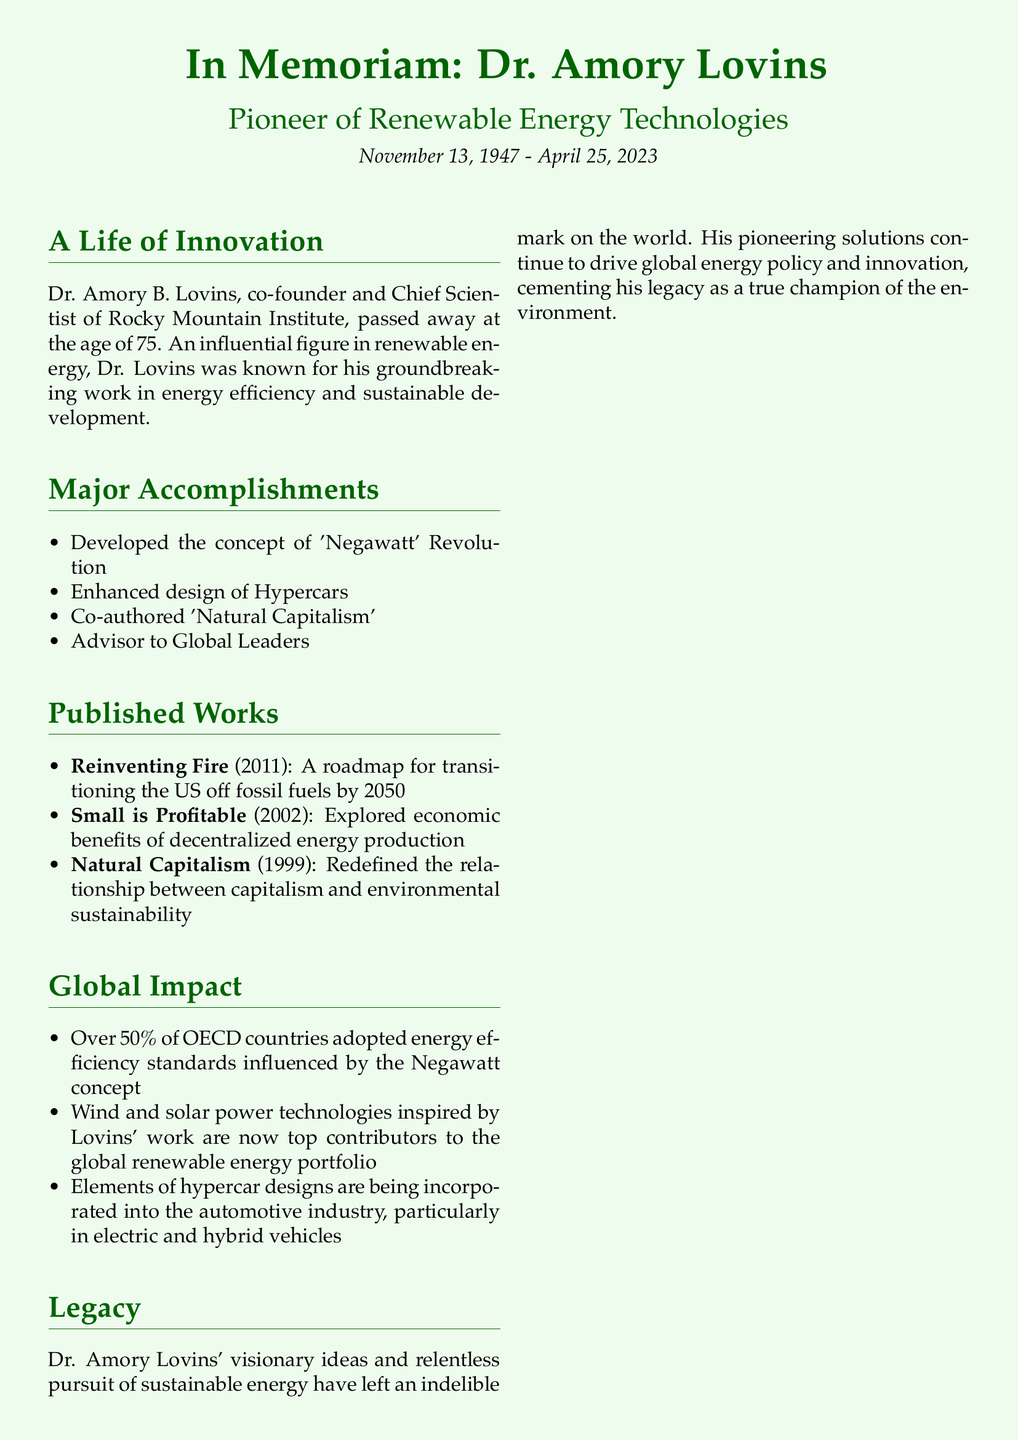What is the full name of the environmental scientist? The document mentions Dr. Amory B. Lovins as the full name of the environmental scientist.
Answer: Dr. Amory B. Lovins When was Dr. Amory Lovins born? The obituary states that Dr. Lovins was born on November 13, 1947.
Answer: November 13, 1947 What is one of the major concepts developed by Dr. Lovins? The document highlights the 'Negawatt' Revolution as one of Lovins' major accomplishments.
Answer: Negawatt Revolution Which book did Dr. Lovins co-author in 1999? The document names 'Natural Capitalism' as the book co-authored by Dr. Lovins in 1999.
Answer: Natural Capitalism What percentage of OECD countries adopted energy efficiency standards influenced by Dr. Lovins' work? The obituary notes that over 50% of OECD countries adopted energy efficiency standards influenced by the Negawatt concept.
Answer: Over 50% What type of car designs influenced the automotive industry according to the document? The document states that elements of hypercar designs are being incorporated into the automotive industry.
Answer: Hypercars What was Dr. Lovins' role at Rocky Mountain Institute? Dr. Lovins is identified as the co-founder and Chief Scientist of Rocky Mountain Institute.
Answer: Chief Scientist What is a significant global impact of Lovins' work in renewable energy technologies? The document emphasizes that wind and solar power technologies inspired by Lovins' work are significant contributors to the global renewable energy portfolio.
Answer: Wind and solar power technologies In what year was "Reinventing Fire" published? The obituary mentions that "Reinventing Fire" was published in 2011.
Answer: 2011 